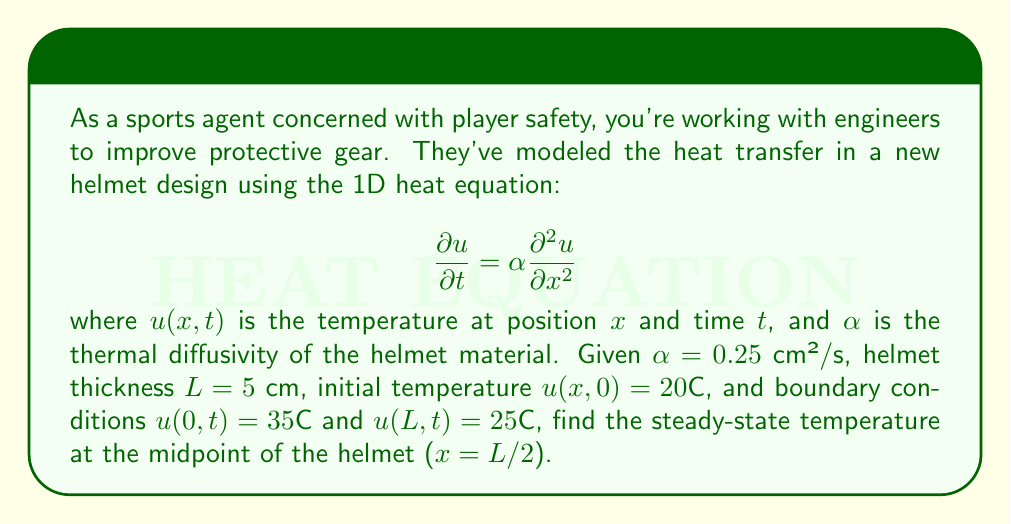Give your solution to this math problem. To solve this problem, we'll follow these steps:

1) For the steady-state solution, the temperature doesn't change with time, so $\frac{\partial u}{\partial t} = 0$. The heat equation reduces to:

   $$0 = \alpha \frac{d^2 u}{dx^2}$$

2) Integrate this twice:

   $$\frac{du}{dx} = C_1$$
   $$u(x) = C_1x + C_2$$

3) Apply the boundary conditions:

   At $x = 0$: $u(0) = 35°C = C_2$
   At $x = L = 5$ cm: $u(5) = 25°C = 5C_1 + 35$

4) Solve for $C_1$:

   $$25 = 5C_1 + 35$$
   $$C_1 = -2°C/cm$$

5) The steady-state temperature distribution is:

   $$u(x) = -2x + 35$$

6) At the midpoint, $x = L/2 = 2.5$ cm:

   $$u(2.5) = -2(2.5) + 35 = 30°C$$
Answer: 30°C 